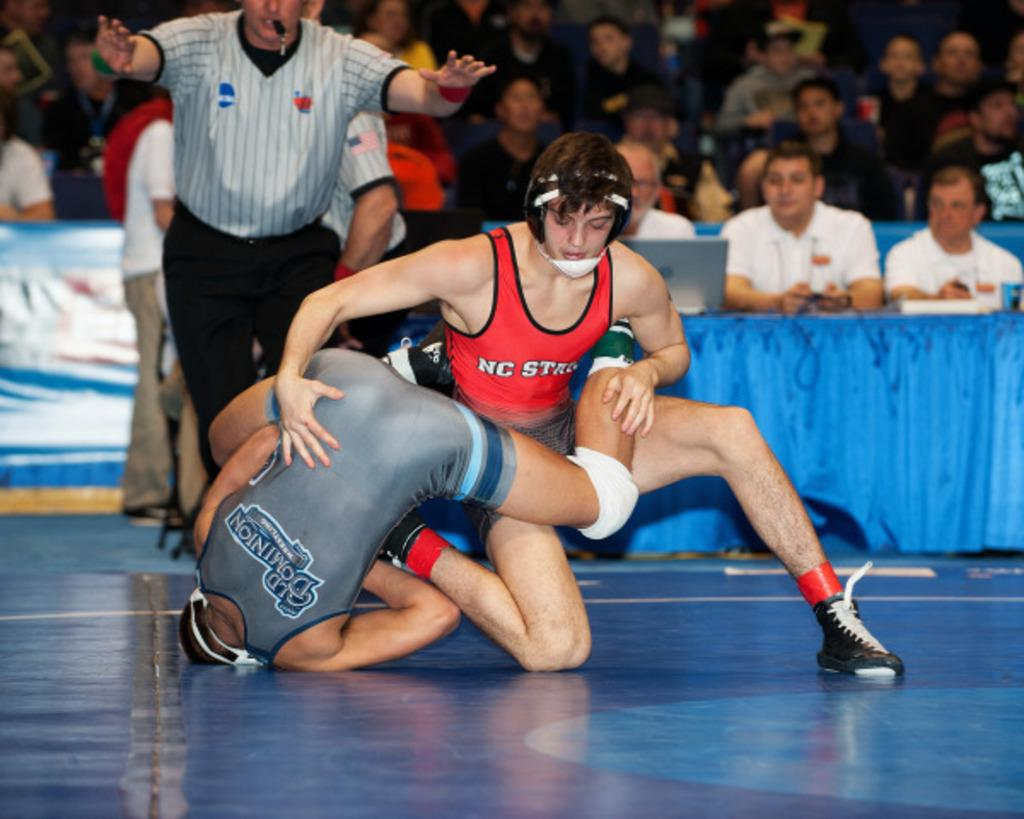<image>
Share a concise interpretation of the image provided. The wrestler in the red jersey is from NC State. 